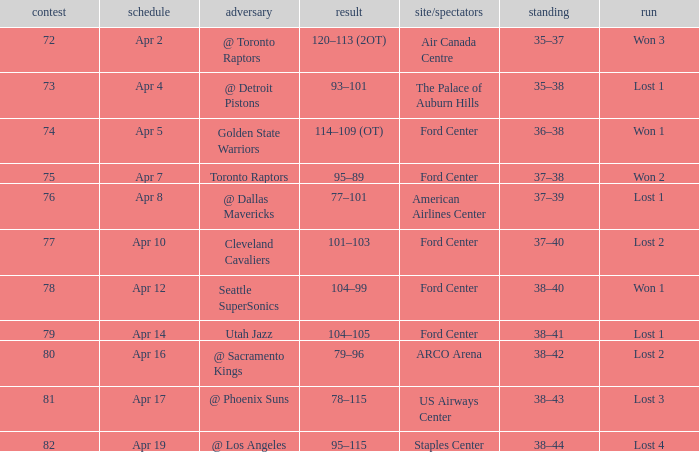Who was the opponent for game 75? Toronto Raptors. 